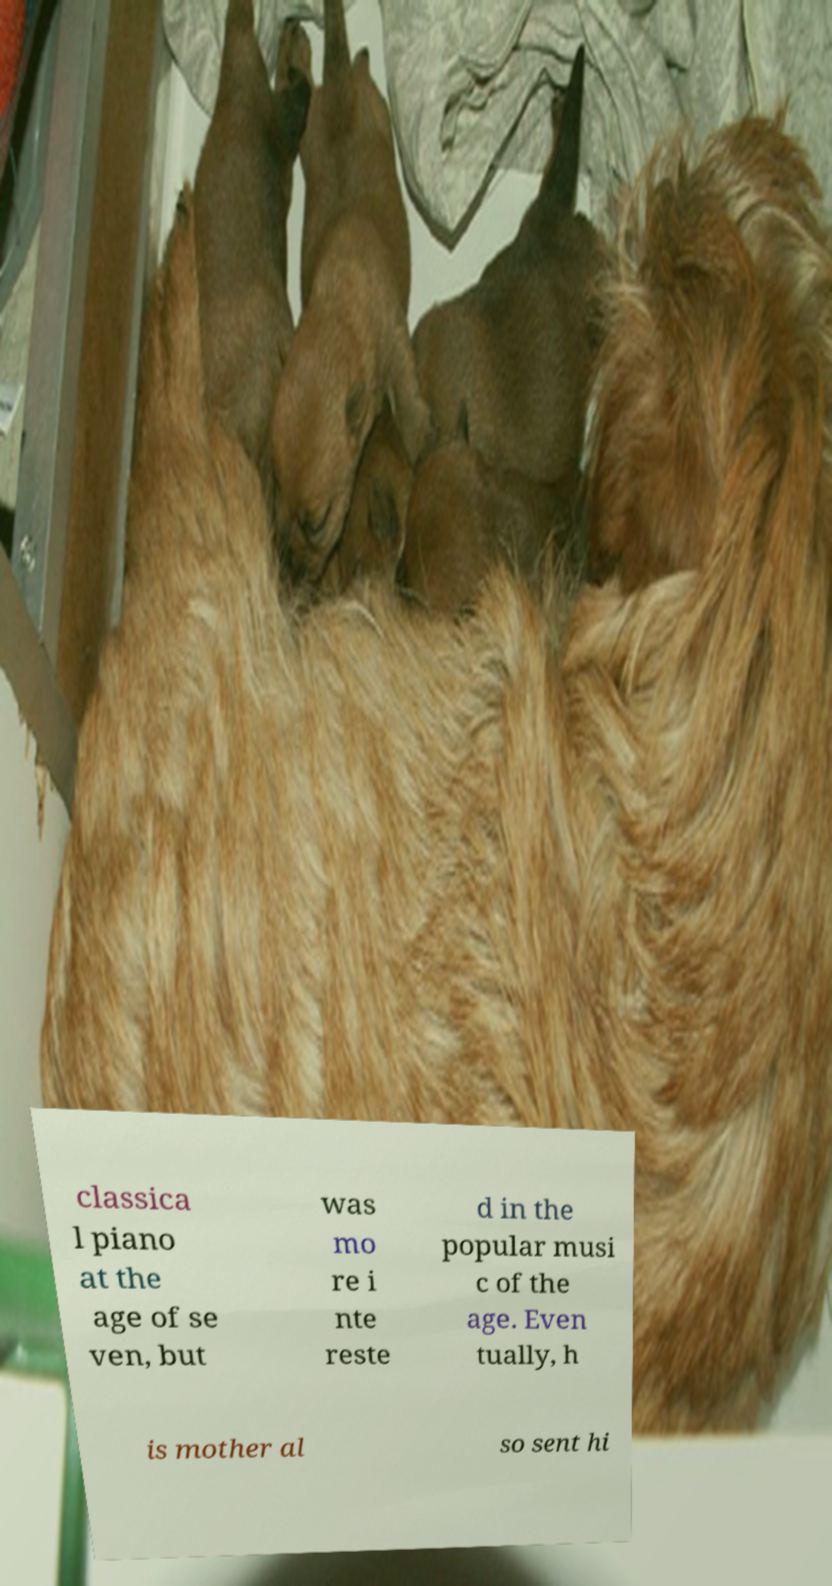Can you accurately transcribe the text from the provided image for me? classica l piano at the age of se ven, but was mo re i nte reste d in the popular musi c of the age. Even tually, h is mother al so sent hi 